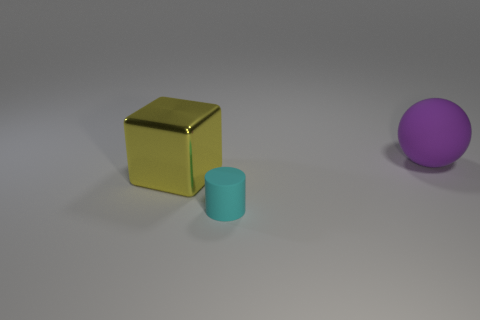What can you infer about the lighting in this scene? The lighting in the scene appears to be diffused and soft, possibly from an overhead source. This is indicated by the gentle shadows under the objects and the lack of harsh glare, which contributes to the calm mood of the composition. 